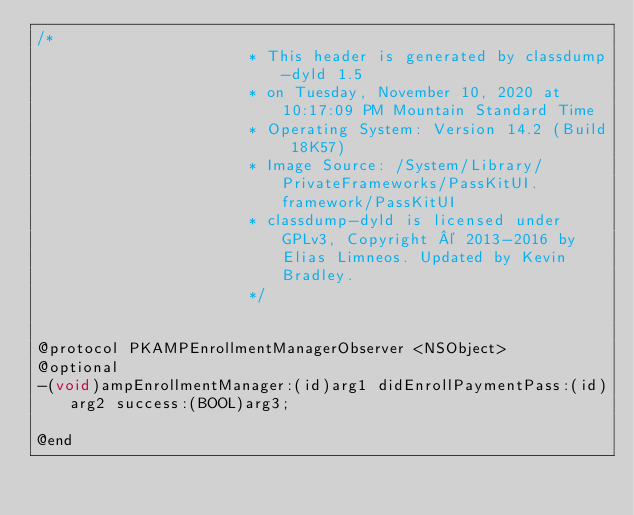<code> <loc_0><loc_0><loc_500><loc_500><_C_>/*
                       * This header is generated by classdump-dyld 1.5
                       * on Tuesday, November 10, 2020 at 10:17:09 PM Mountain Standard Time
                       * Operating System: Version 14.2 (Build 18K57)
                       * Image Source: /System/Library/PrivateFrameworks/PassKitUI.framework/PassKitUI
                       * classdump-dyld is licensed under GPLv3, Copyright © 2013-2016 by Elias Limneos. Updated by Kevin Bradley.
                       */


@protocol PKAMPEnrollmentManagerObserver <NSObject>
@optional
-(void)ampEnrollmentManager:(id)arg1 didEnrollPaymentPass:(id)arg2 success:(BOOL)arg3;

@end

</code> 